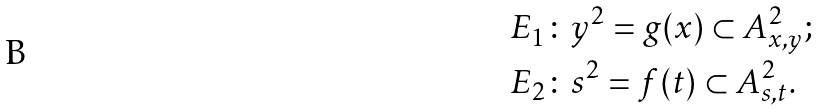<formula> <loc_0><loc_0><loc_500><loc_500>& E _ { 1 } \colon y ^ { 2 } = g ( x ) \subset A ^ { 2 } _ { x , y } ; \\ & E _ { 2 } \colon s ^ { 2 } = f ( t ) \subset A ^ { 2 } _ { s , t } .</formula> 